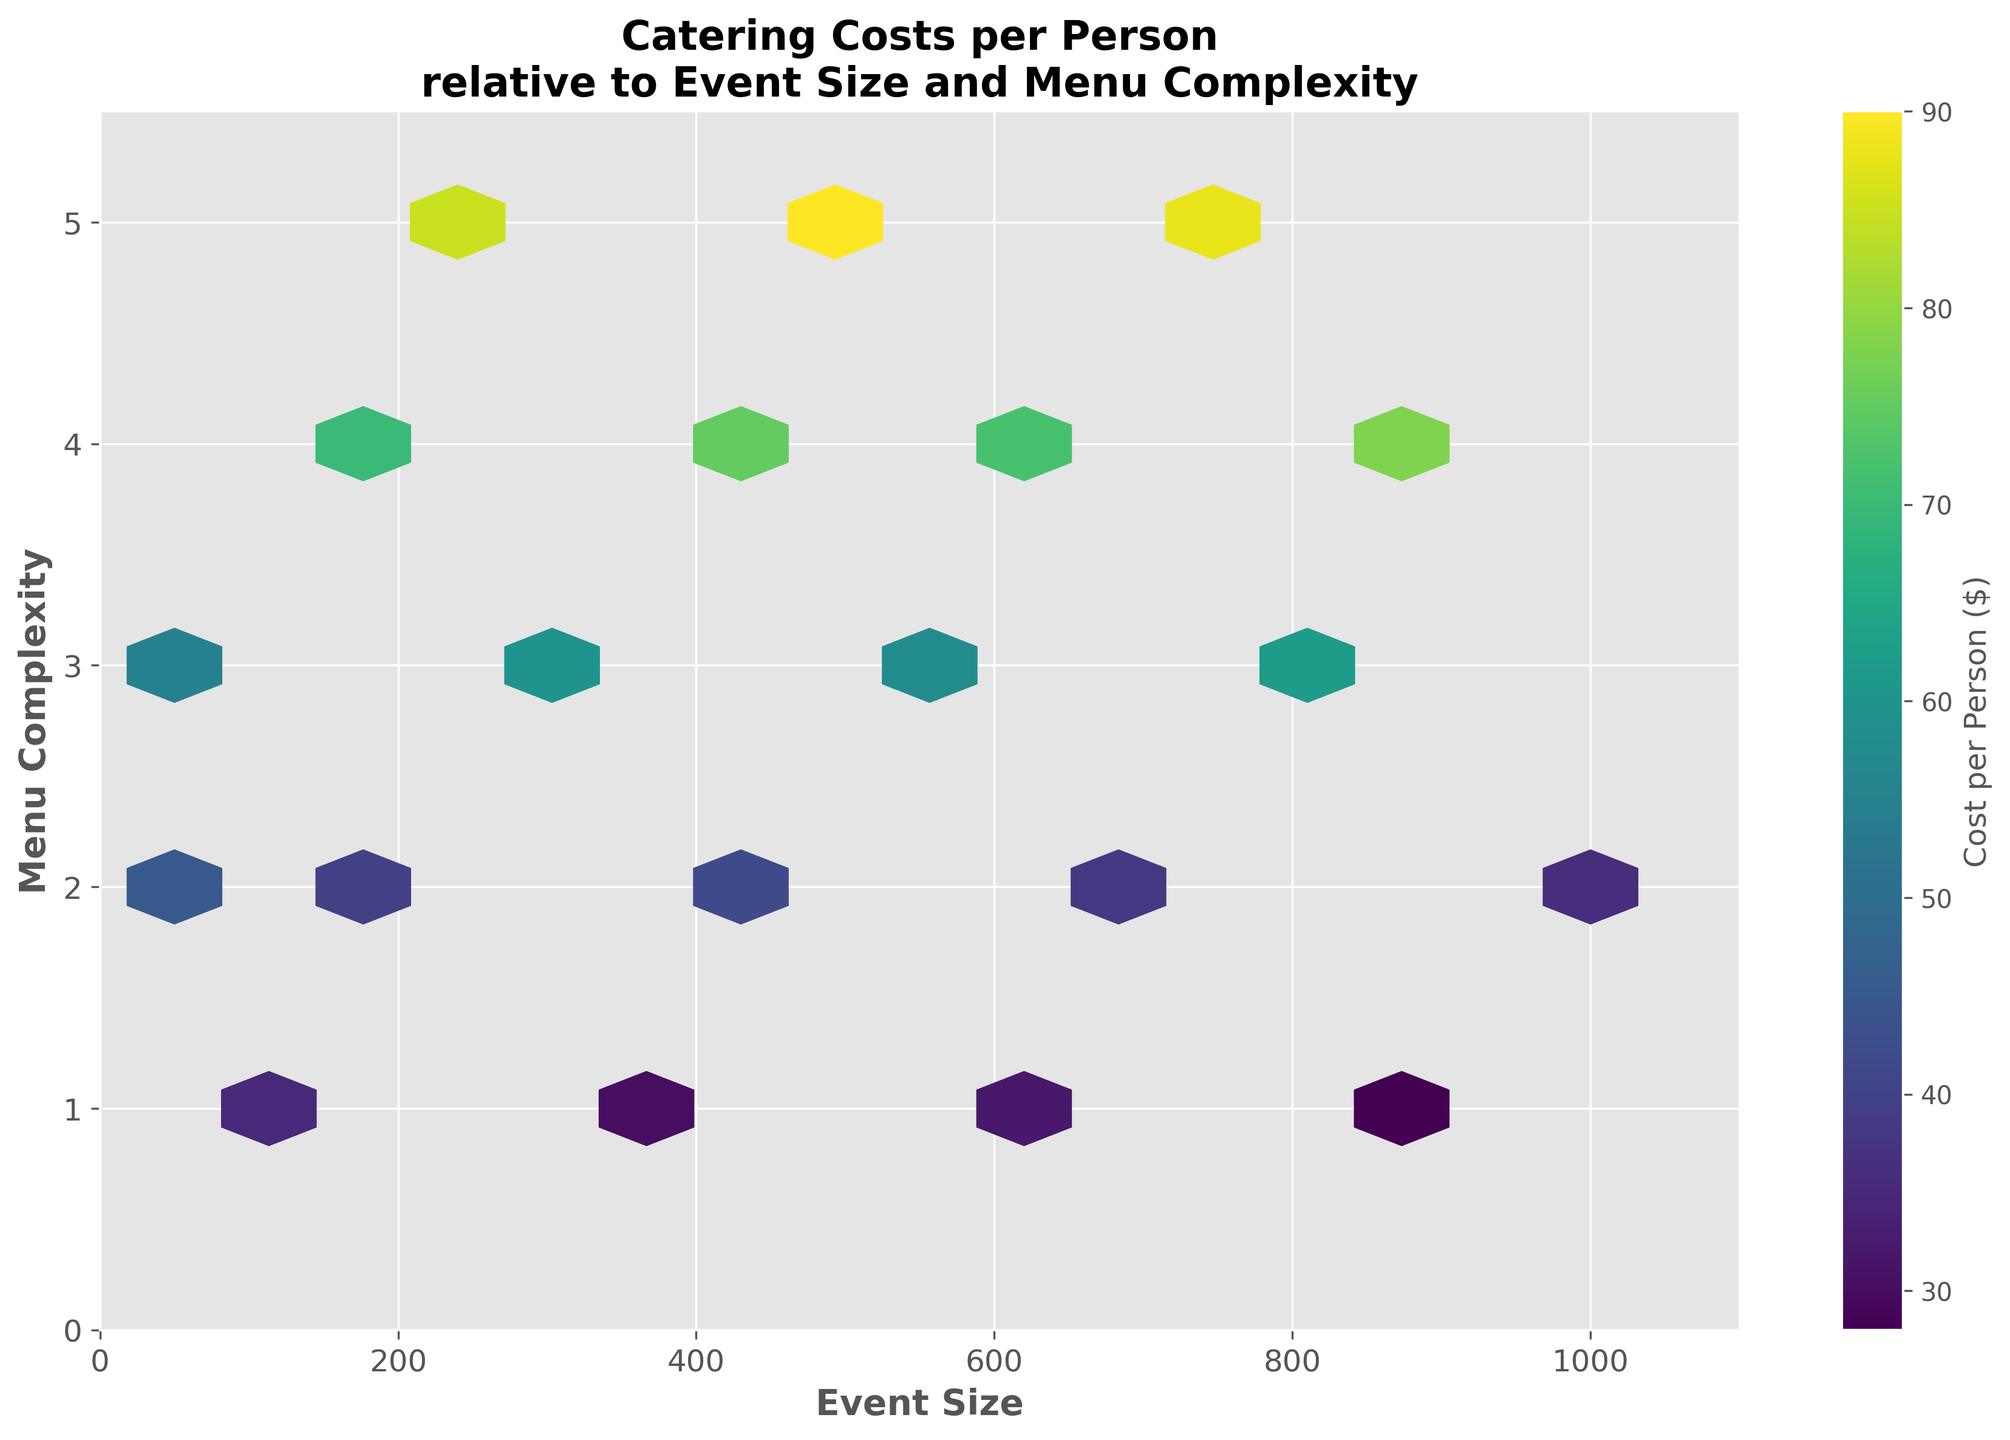Do the values of 'Event Size' and 'Menu Complexity' increase linearly in the figure? The hexbin plot shows 'Event Size' on the x-axis and 'Menu Complexity' on the y-axis. Observing the distribution of the points, there does not appear to be a linear increase between 'Event Size' and 'Menu Complexity'. The hexagons are scattered, indicating varying values independent of a linear relationship.
Answer: No What is the color range indicating in the plot? The hexbin plot uses color to represent the 'Cost per Person'. The color bar on the side shows the gradient of costs, with different shades representing the range from the lowest to the highest catering cost per person.
Answer: Cost per Person At what 'Event Size' and 'Menu Complexity' is the average 'Cost per Person' the highest? By observing the hexbin plot and the color intensity, the darker region implies a higher average cost. Scanning the plot, it appears that the highest concentration of dark-colored hexagons is around a higher 'Event Size' (near 750) and a high 'Menu Complexity' (around 5).
Answer: Event Size: 750, Menu Complexity: 5 How does 'Cost per Person' change with increasing 'Event Size' when the 'Menu Complexity' is low? For low 'Menu Complexity' (closer to 1), as 'Event Size' increases, the 'Cost per Person' generally seems lower. The lower costs are represented by lighter colors. Hence, larger events with simpler menus tend to have lower per person costs.
Answer: Costs decrease Is there any range of 'Event Size' where 'Menu Complexity' does not significantly impact 'Cost per Person'? Observing the hexbin plot, between the 'Event Size' range of approximately 200 to 400, the color differences are less pronounced regardless of the 'Menu Complexity', indicating more consistent costs within this range.
Answer: 200 - 400 Which 'Menu Complexity' level has the lowest 'Cost per Person' and at what 'Event Size'? The area with the lightest color indicates the lowest cost. Around 'Menu Complexity' of 1 and 'Event Size' near 850, the color is the lightest, representing the lowest cost per person.
Answer: Menu Complexity: 1, Event Size: 850 How does the distribution of costs change as 'Event Size' increases? From the hexbin plot, as 'Event Size' increases, the range of 'Cost per Person' widens. This is visible from the range of color intensities spreading out more as the event size increases, indicating more variability in costs.
Answer: Widens Are there more high-cost events at higher or lower 'Menu Complexity' levels? Higher costs are represented by darker hexagons. These darker regions are observed more frequently at higher 'Menu Complexity' levels (closer to 5), suggesting more high-cost events with complex menus.
Answer: Higher Is there a cluster of low-cost events in relation to 'Event Size' and 'Menu Complexity'? Scanning for the lighter-colored hexagons, clusters of low-cost events appear most prominently around lower 'Event Size' (around 50-100) and lower 'Menu Complexity' (closer to 1).
Answer: Yes, lower 'Event Size' and 'Menu Complexity' If you wanted to plan an event with a 'Menu Complexity' of 3, what 'Event Size' would likely yield a mid-range 'Cost per Person'? Mid-range costs are represented by middle shades (not too light or dark). For 'Menu Complexity' of 3, examining the plot, an 'Event Size' of around 300-400 seems to fall into the mid-range costs.
Answer: Event Size: 300-400 